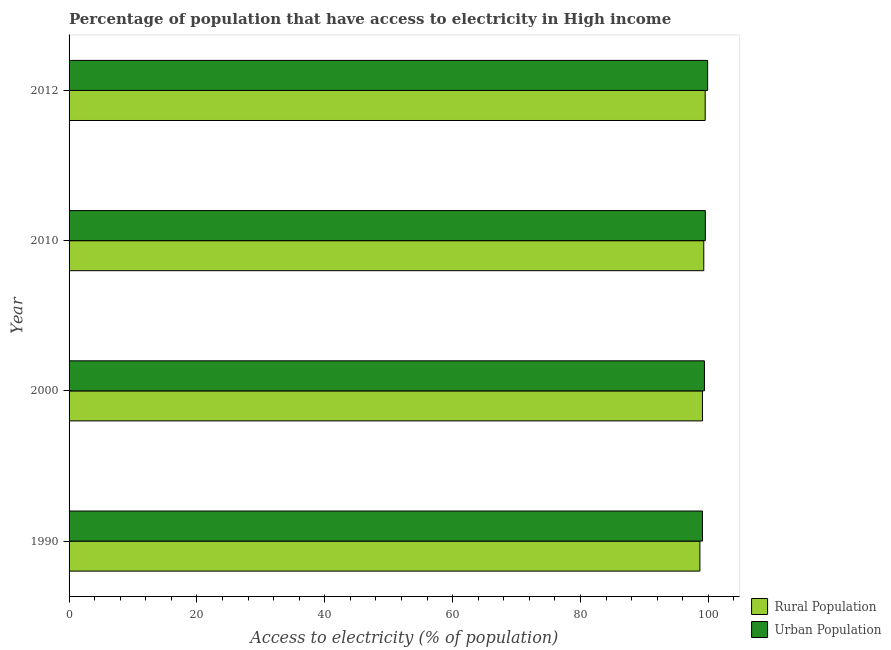How many different coloured bars are there?
Offer a terse response. 2. Are the number of bars per tick equal to the number of legend labels?
Your response must be concise. Yes. What is the label of the 4th group of bars from the top?
Make the answer very short. 1990. What is the percentage of urban population having access to electricity in 1990?
Give a very brief answer. 99.07. Across all years, what is the maximum percentage of rural population having access to electricity?
Your response must be concise. 99.5. Across all years, what is the minimum percentage of rural population having access to electricity?
Offer a very short reply. 98.67. In which year was the percentage of urban population having access to electricity minimum?
Provide a short and direct response. 1990. What is the total percentage of urban population having access to electricity in the graph?
Provide a succinct answer. 397.87. What is the difference between the percentage of urban population having access to electricity in 2010 and that in 2012?
Provide a short and direct response. -0.36. What is the difference between the percentage of urban population having access to electricity in 2000 and the percentage of rural population having access to electricity in 2010?
Make the answer very short. 0.1. What is the average percentage of urban population having access to electricity per year?
Keep it short and to the point. 99.47. In the year 2010, what is the difference between the percentage of rural population having access to electricity and percentage of urban population having access to electricity?
Provide a short and direct response. -0.24. What is the ratio of the percentage of urban population having access to electricity in 1990 to that in 2000?
Provide a short and direct response. 1. Is the percentage of urban population having access to electricity in 2000 less than that in 2012?
Offer a terse response. Yes. What is the difference between the highest and the second highest percentage of urban population having access to electricity?
Provide a short and direct response. 0.36. What is the difference between the highest and the lowest percentage of rural population having access to electricity?
Keep it short and to the point. 0.83. What does the 1st bar from the top in 2012 represents?
Provide a short and direct response. Urban Population. What does the 1st bar from the bottom in 2012 represents?
Your response must be concise. Rural Population. How many bars are there?
Offer a very short reply. 8. How many years are there in the graph?
Give a very brief answer. 4. Are the values on the major ticks of X-axis written in scientific E-notation?
Your response must be concise. No. Does the graph contain any zero values?
Offer a very short reply. No. Does the graph contain grids?
Make the answer very short. No. Where does the legend appear in the graph?
Your answer should be compact. Bottom right. How are the legend labels stacked?
Make the answer very short. Vertical. What is the title of the graph?
Provide a short and direct response. Percentage of population that have access to electricity in High income. What is the label or title of the X-axis?
Make the answer very short. Access to electricity (% of population). What is the Access to electricity (% of population) in Rural Population in 1990?
Your answer should be very brief. 98.67. What is the Access to electricity (% of population) in Urban Population in 1990?
Ensure brevity in your answer.  99.07. What is the Access to electricity (% of population) in Rural Population in 2000?
Give a very brief answer. 99.08. What is the Access to electricity (% of population) of Urban Population in 2000?
Offer a terse response. 99.38. What is the Access to electricity (% of population) of Rural Population in 2010?
Provide a short and direct response. 99.28. What is the Access to electricity (% of population) in Urban Population in 2010?
Offer a very short reply. 99.53. What is the Access to electricity (% of population) in Rural Population in 2012?
Make the answer very short. 99.5. What is the Access to electricity (% of population) in Urban Population in 2012?
Your answer should be compact. 99.89. Across all years, what is the maximum Access to electricity (% of population) of Rural Population?
Make the answer very short. 99.5. Across all years, what is the maximum Access to electricity (% of population) of Urban Population?
Keep it short and to the point. 99.89. Across all years, what is the minimum Access to electricity (% of population) in Rural Population?
Your answer should be compact. 98.67. Across all years, what is the minimum Access to electricity (% of population) in Urban Population?
Give a very brief answer. 99.07. What is the total Access to electricity (% of population) in Rural Population in the graph?
Give a very brief answer. 396.54. What is the total Access to electricity (% of population) in Urban Population in the graph?
Offer a very short reply. 397.87. What is the difference between the Access to electricity (% of population) in Rural Population in 1990 and that in 2000?
Your answer should be very brief. -0.4. What is the difference between the Access to electricity (% of population) of Urban Population in 1990 and that in 2000?
Ensure brevity in your answer.  -0.31. What is the difference between the Access to electricity (% of population) of Rural Population in 1990 and that in 2010?
Offer a very short reply. -0.61. What is the difference between the Access to electricity (% of population) of Urban Population in 1990 and that in 2010?
Offer a terse response. -0.45. What is the difference between the Access to electricity (% of population) of Rural Population in 1990 and that in 2012?
Your answer should be compact. -0.83. What is the difference between the Access to electricity (% of population) of Urban Population in 1990 and that in 2012?
Keep it short and to the point. -0.81. What is the difference between the Access to electricity (% of population) in Rural Population in 2000 and that in 2010?
Give a very brief answer. -0.21. What is the difference between the Access to electricity (% of population) in Urban Population in 2000 and that in 2010?
Your response must be concise. -0.14. What is the difference between the Access to electricity (% of population) in Rural Population in 2000 and that in 2012?
Your answer should be very brief. -0.43. What is the difference between the Access to electricity (% of population) of Urban Population in 2000 and that in 2012?
Keep it short and to the point. -0.5. What is the difference between the Access to electricity (% of population) in Rural Population in 2010 and that in 2012?
Keep it short and to the point. -0.22. What is the difference between the Access to electricity (% of population) in Urban Population in 2010 and that in 2012?
Keep it short and to the point. -0.36. What is the difference between the Access to electricity (% of population) of Rural Population in 1990 and the Access to electricity (% of population) of Urban Population in 2000?
Offer a very short reply. -0.71. What is the difference between the Access to electricity (% of population) in Rural Population in 1990 and the Access to electricity (% of population) in Urban Population in 2010?
Give a very brief answer. -0.85. What is the difference between the Access to electricity (% of population) in Rural Population in 1990 and the Access to electricity (% of population) in Urban Population in 2012?
Offer a terse response. -1.21. What is the difference between the Access to electricity (% of population) in Rural Population in 2000 and the Access to electricity (% of population) in Urban Population in 2010?
Ensure brevity in your answer.  -0.45. What is the difference between the Access to electricity (% of population) in Rural Population in 2000 and the Access to electricity (% of population) in Urban Population in 2012?
Your response must be concise. -0.81. What is the difference between the Access to electricity (% of population) in Rural Population in 2010 and the Access to electricity (% of population) in Urban Population in 2012?
Your answer should be very brief. -0.6. What is the average Access to electricity (% of population) of Rural Population per year?
Make the answer very short. 99.13. What is the average Access to electricity (% of population) of Urban Population per year?
Ensure brevity in your answer.  99.47. In the year 1990, what is the difference between the Access to electricity (% of population) of Rural Population and Access to electricity (% of population) of Urban Population?
Make the answer very short. -0.4. In the year 2000, what is the difference between the Access to electricity (% of population) of Rural Population and Access to electricity (% of population) of Urban Population?
Ensure brevity in your answer.  -0.3. In the year 2010, what is the difference between the Access to electricity (% of population) of Rural Population and Access to electricity (% of population) of Urban Population?
Make the answer very short. -0.24. In the year 2012, what is the difference between the Access to electricity (% of population) in Rural Population and Access to electricity (% of population) in Urban Population?
Your answer should be compact. -0.38. What is the ratio of the Access to electricity (% of population) of Rural Population in 1990 to that in 2012?
Your answer should be compact. 0.99. What is the ratio of the Access to electricity (% of population) of Urban Population in 2000 to that in 2012?
Your answer should be compact. 0.99. What is the ratio of the Access to electricity (% of population) in Rural Population in 2010 to that in 2012?
Offer a very short reply. 1. What is the difference between the highest and the second highest Access to electricity (% of population) in Rural Population?
Ensure brevity in your answer.  0.22. What is the difference between the highest and the second highest Access to electricity (% of population) of Urban Population?
Provide a succinct answer. 0.36. What is the difference between the highest and the lowest Access to electricity (% of population) in Rural Population?
Offer a very short reply. 0.83. What is the difference between the highest and the lowest Access to electricity (% of population) of Urban Population?
Offer a very short reply. 0.81. 